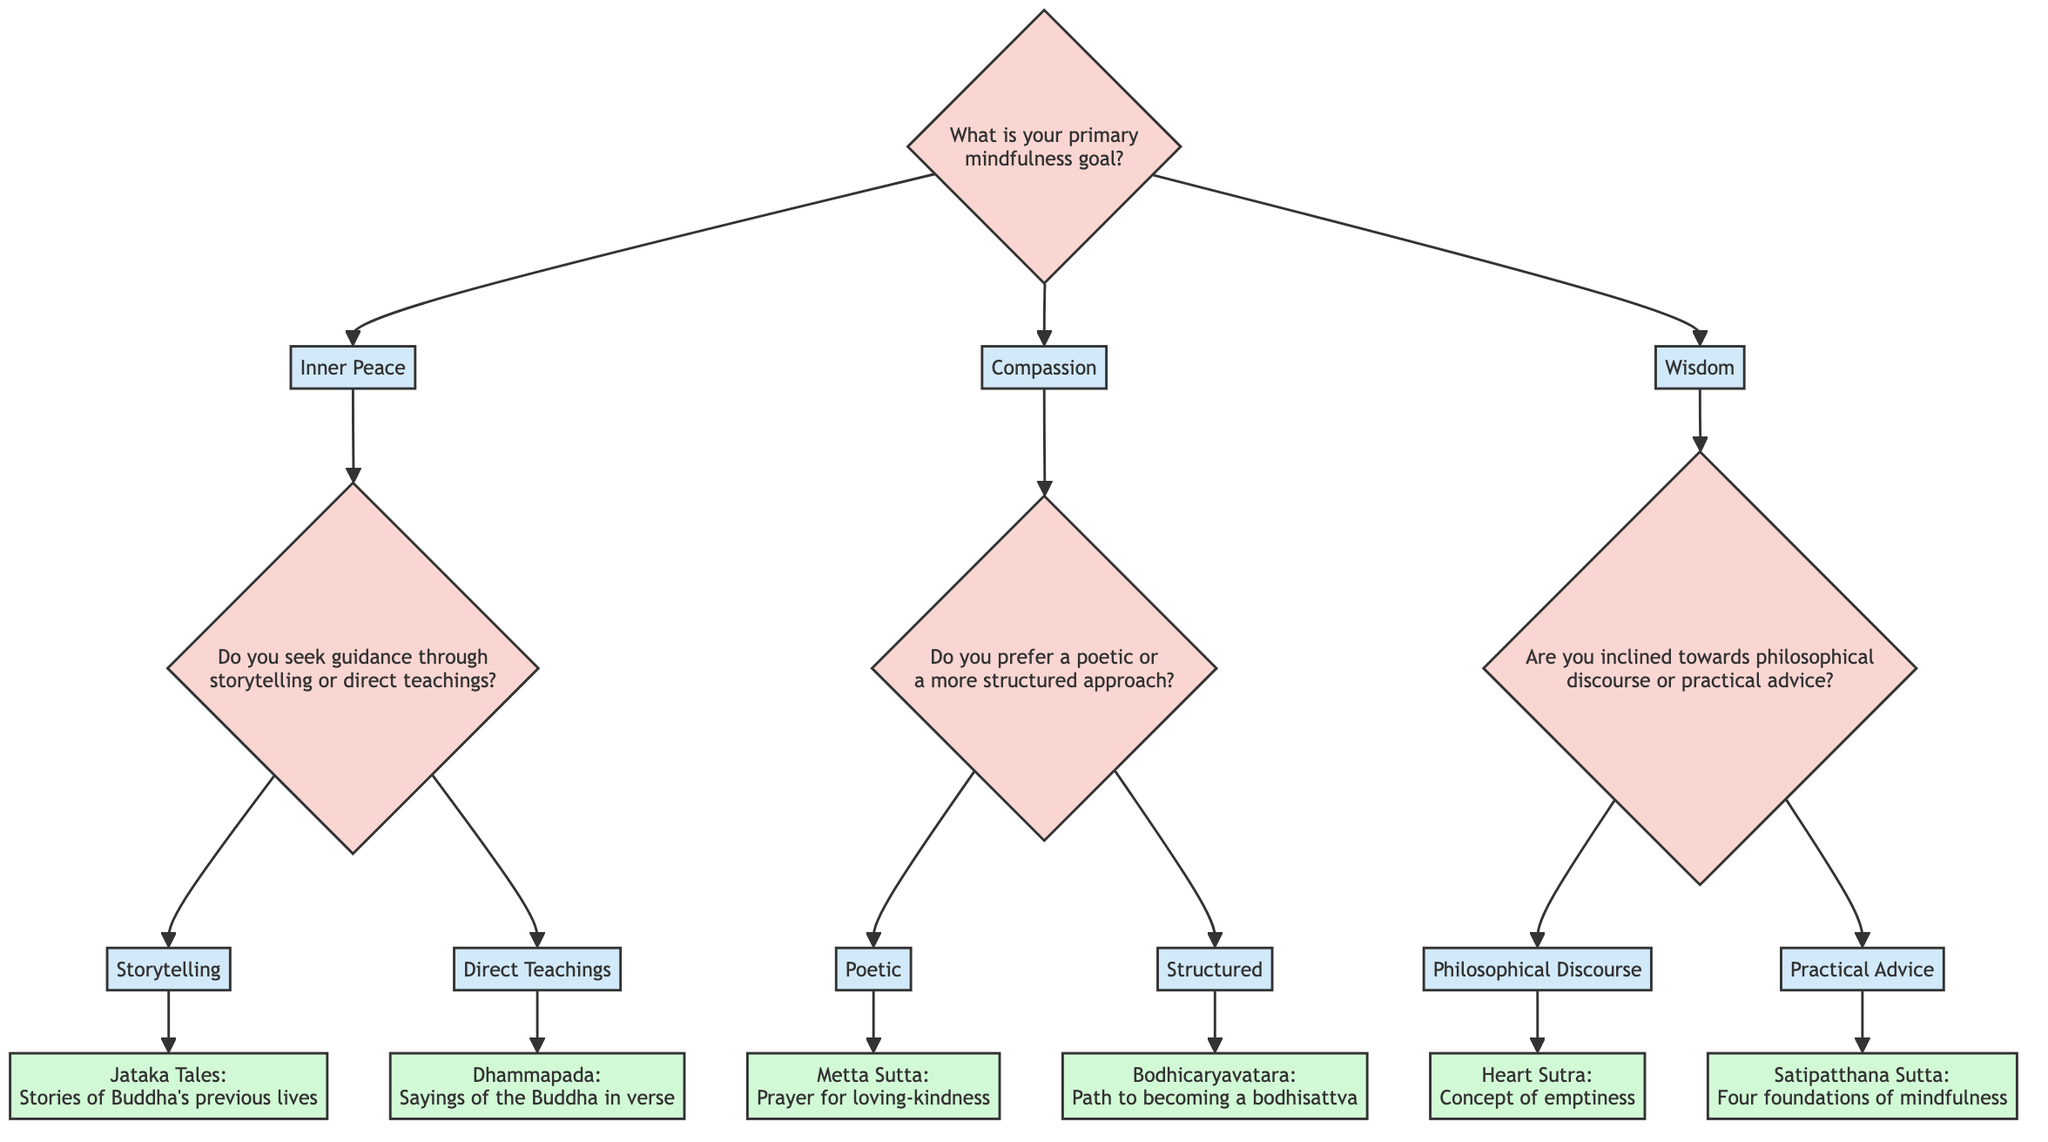What are the main mindfulness goals presented in the diagram? The diagram shows three main mindfulness goals: Inner Peace, Compassion, and Wisdom. These are the first level nodes branching out from the start node.
Answer: Inner Peace, Compassion, Wisdom Which text is associated with the option "Structured" under the goal of Compassion? To find this, follow the Compassion node and observe the options available. The "Structured" option leads to the Bodhicaryavatara.
Answer: Bodhicaryavatara How many options are available for the goal of Inner Peace? There are two options available under Inner Peace: Storytelling and Direct Teachings, branching out from the Inner Peace node.
Answer: 2 What is the description of the Metta Sutta? Starting from the Compassion goal and going to the Poetic option leads to the Metta Sutta, described as a prayer for loving-kindness that helps cultivate compassion and non-violence towards all beings.
Answer: A prayer for loving-kindness Which two categories of mindfulness go to philosophical discourse under Wisdom? The node for Wisdom lists two branches: Philosophical Discourse and Practical Advice. To reach "Philosophical Discourse," we trace one branch from Wisdom.
Answer: Philosophical Discourse What is the primary question asked at the start of the diagram? The initial question, labeled at the Start node, is "What is your primary mindfulness goal?" This inquiry sets the stage for the decision-making process that follows.
Answer: What is your primary mindfulness goal? If a person chooses "Storytelling," which text will they study? By tracing the Inner Peace node and selecting Storytelling, the flow leads to the Jataka Tales, thus identifying the text chosen for study based on this option.
Answer: Jataka Tales Which text correlates with practical advice in the Wisdom category? Following the Wisdom node, selecting Practical Advice leads to the Satipatthana Sutta, identifying the text associated with this option.
Answer: Satipatthana Sutta 